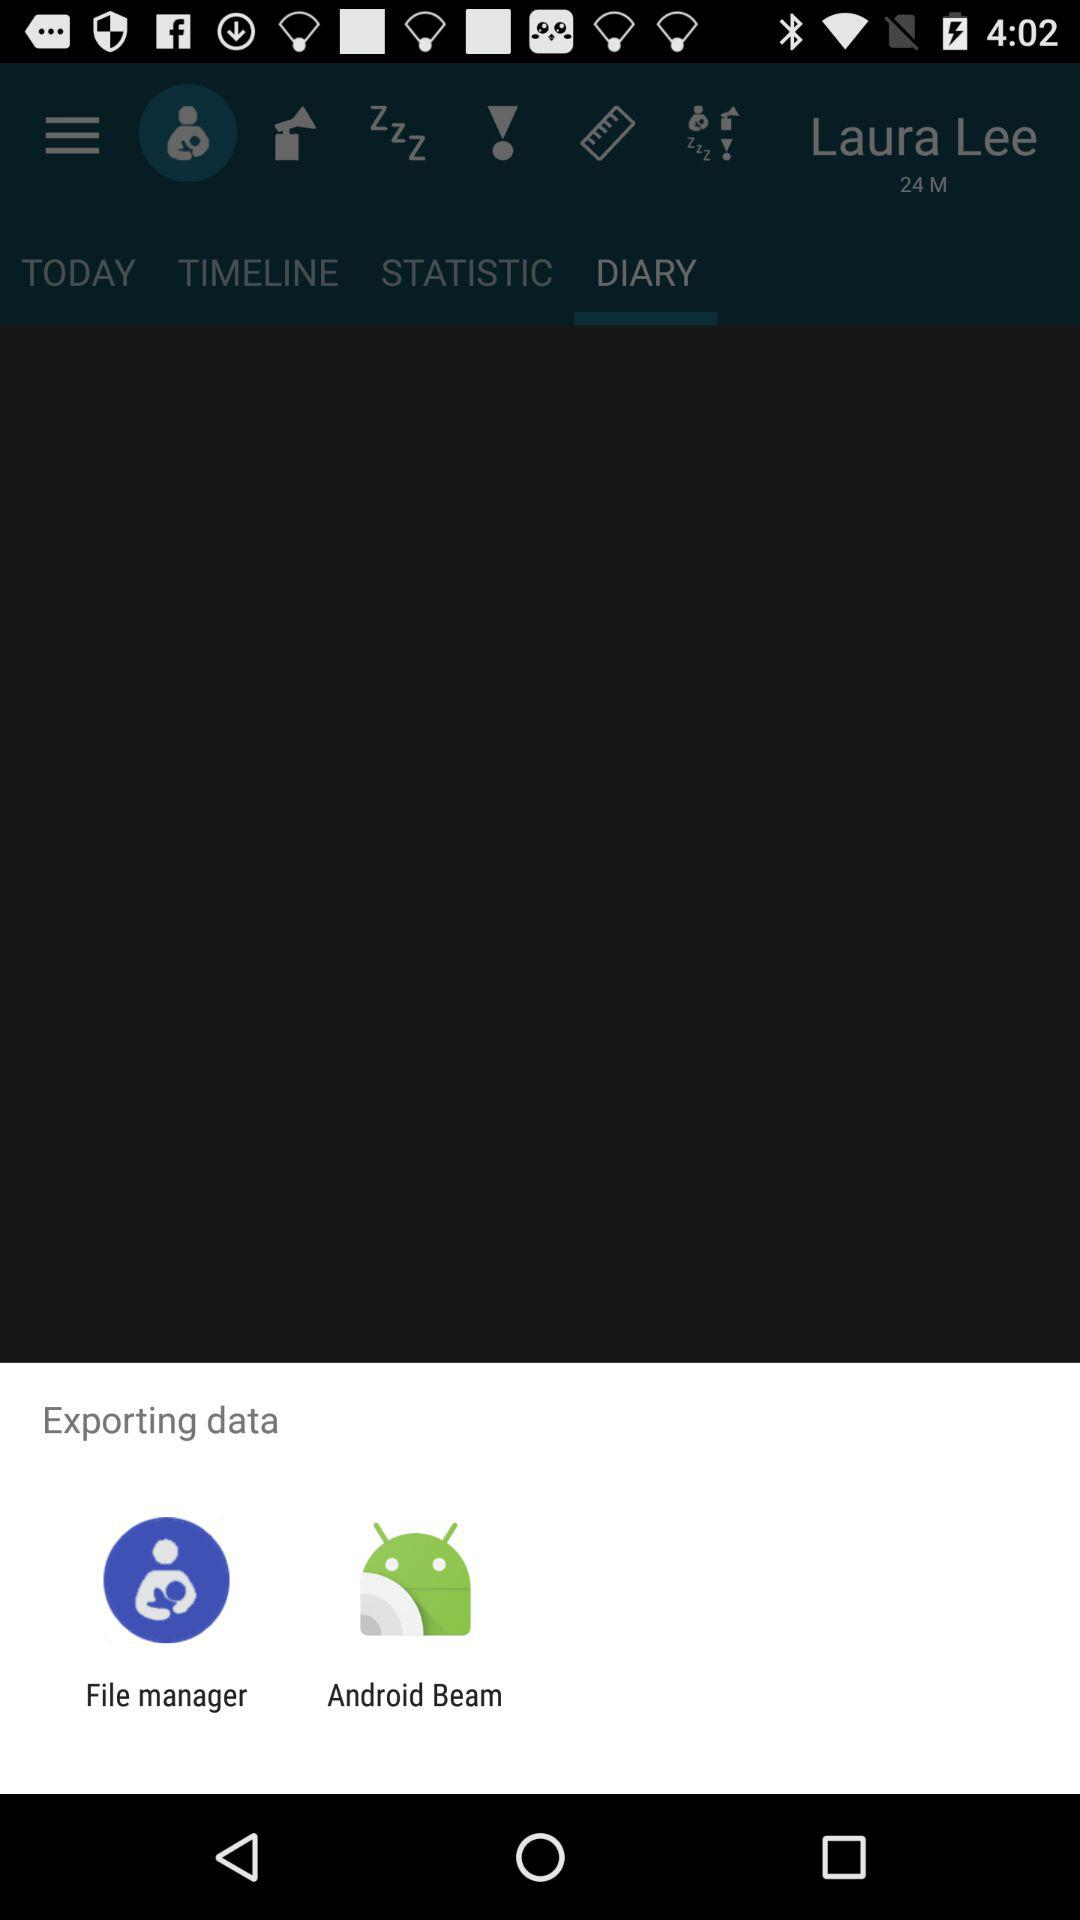Which option has been selected? The selected option is "DIARY". 